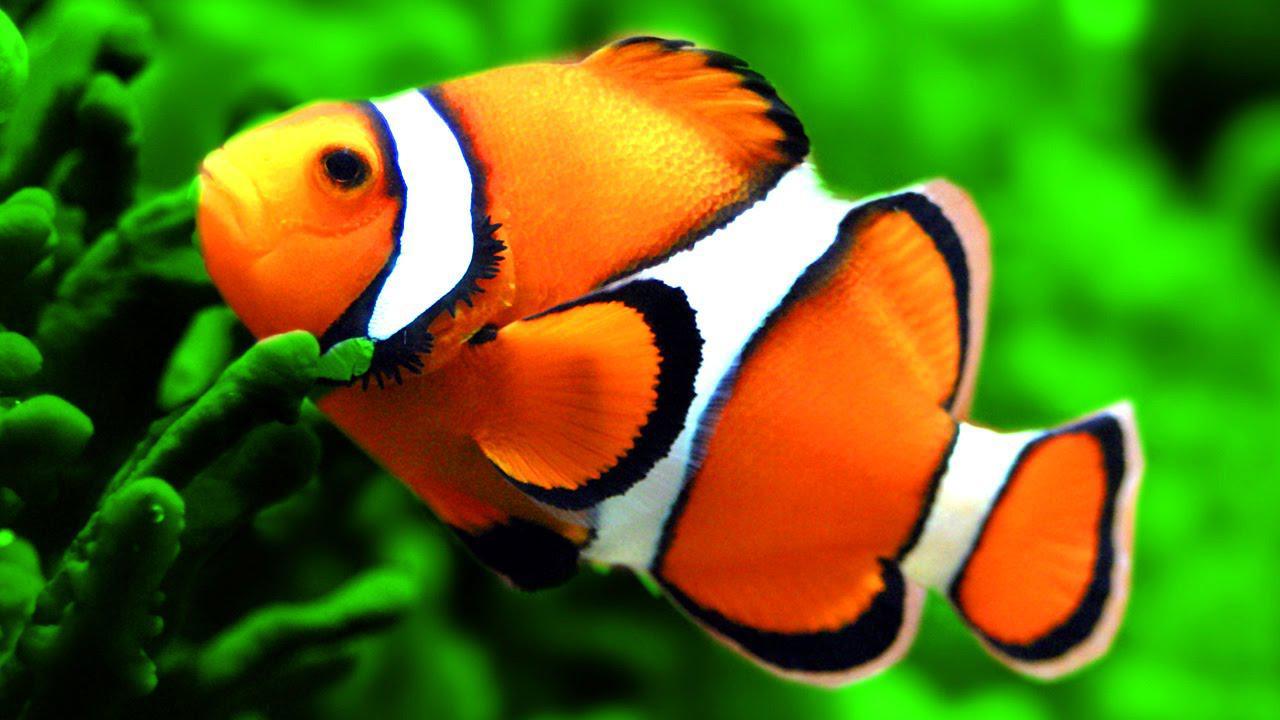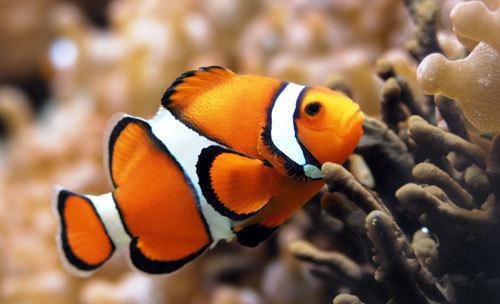The first image is the image on the left, the second image is the image on the right. Examine the images to the left and right. Is the description "At least one image has more than one clown fish." accurate? Answer yes or no. No. 